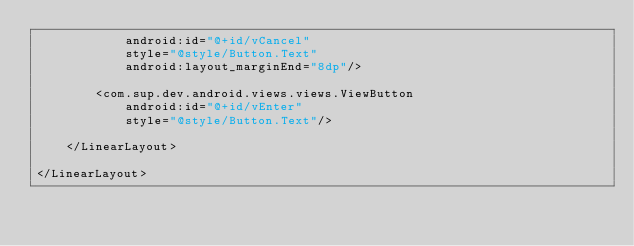Convert code to text. <code><loc_0><loc_0><loc_500><loc_500><_XML_>            android:id="@+id/vCancel"
            style="@style/Button.Text"
            android:layout_marginEnd="8dp"/>

        <com.sup.dev.android.views.views.ViewButton
            android:id="@+id/vEnter"
            style="@style/Button.Text"/>

    </LinearLayout>

</LinearLayout>
</code> 